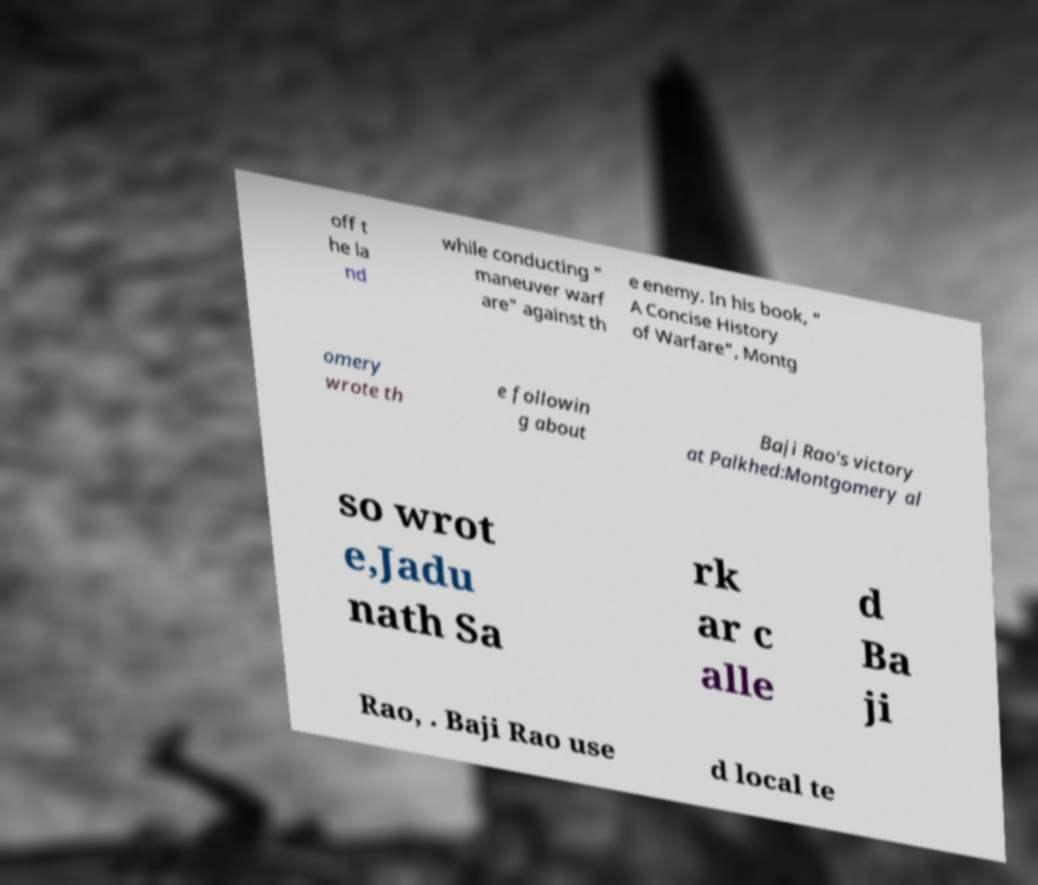Could you extract and type out the text from this image? off t he la nd while conducting " maneuver warf are" against th e enemy. In his book, " A Concise History of Warfare", Montg omery wrote th e followin g about Baji Rao's victory at Palkhed:Montgomery al so wrot e,Jadu nath Sa rk ar c alle d Ba ji Rao, . Baji Rao use d local te 